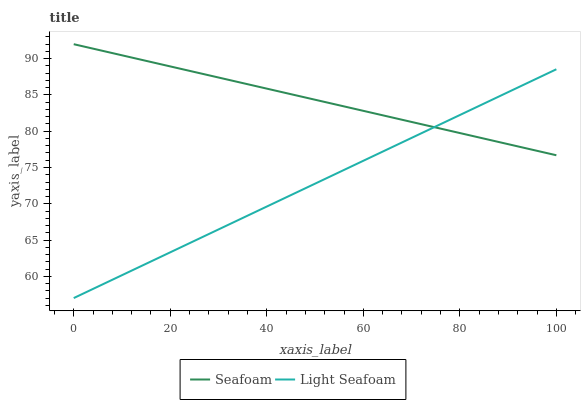Does Light Seafoam have the minimum area under the curve?
Answer yes or no. Yes. Does Seafoam have the maximum area under the curve?
Answer yes or no. Yes. Does Seafoam have the minimum area under the curve?
Answer yes or no. No. Is Light Seafoam the smoothest?
Answer yes or no. Yes. Is Seafoam the roughest?
Answer yes or no. Yes. Is Seafoam the smoothest?
Answer yes or no. No. Does Light Seafoam have the lowest value?
Answer yes or no. Yes. Does Seafoam have the lowest value?
Answer yes or no. No. Does Seafoam have the highest value?
Answer yes or no. Yes. Does Seafoam intersect Light Seafoam?
Answer yes or no. Yes. Is Seafoam less than Light Seafoam?
Answer yes or no. No. Is Seafoam greater than Light Seafoam?
Answer yes or no. No. 